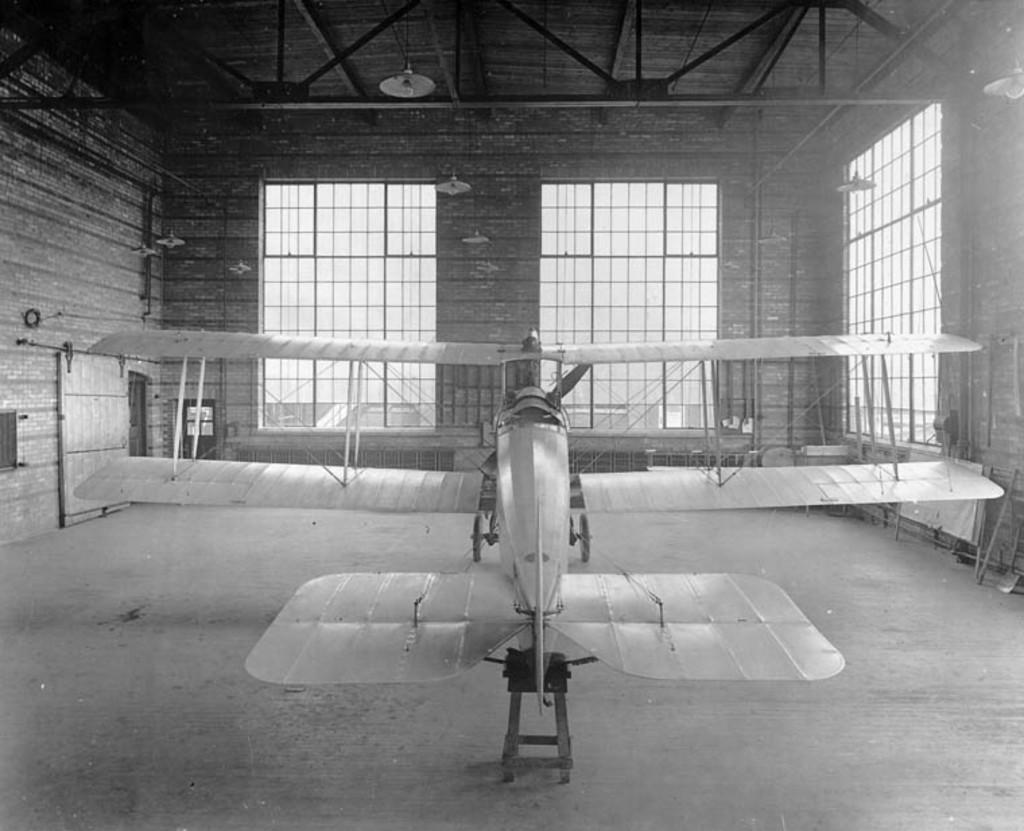What is the main subject of the image? The main subject of the image is an aircraft. How is the aircraft positioned in the image? The aircraft is arranged on the floor in the image. Where is the aircraft located? The aircraft is located inside a building. What features can be seen on the building? The building has windows and a roof. What type of account is being discussed in the image? There is no account being discussed in the image; it features an aircraft arranged on the floor inside a building. Can you see the moon in the image? The moon is not visible in the image; it focuses on an aircraft inside a building. 